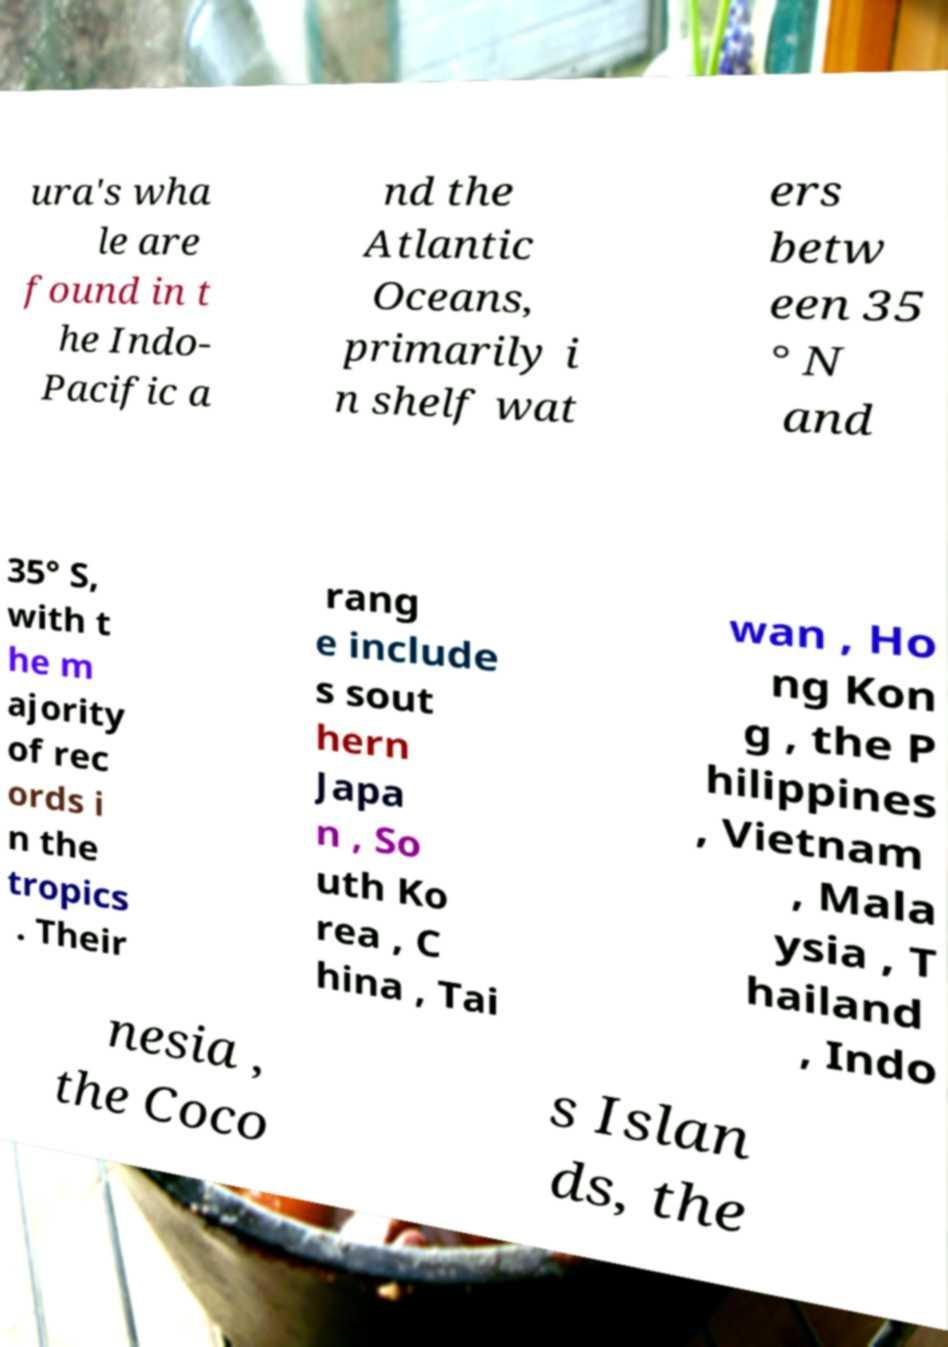Could you extract and type out the text from this image? ura's wha le are found in t he Indo- Pacific a nd the Atlantic Oceans, primarily i n shelf wat ers betw een 35 ° N and 35° S, with t he m ajority of rec ords i n the tropics . Their rang e include s sout hern Japa n , So uth Ko rea , C hina , Tai wan , Ho ng Kon g , the P hilippines , Vietnam , Mala ysia , T hailand , Indo nesia , the Coco s Islan ds, the 